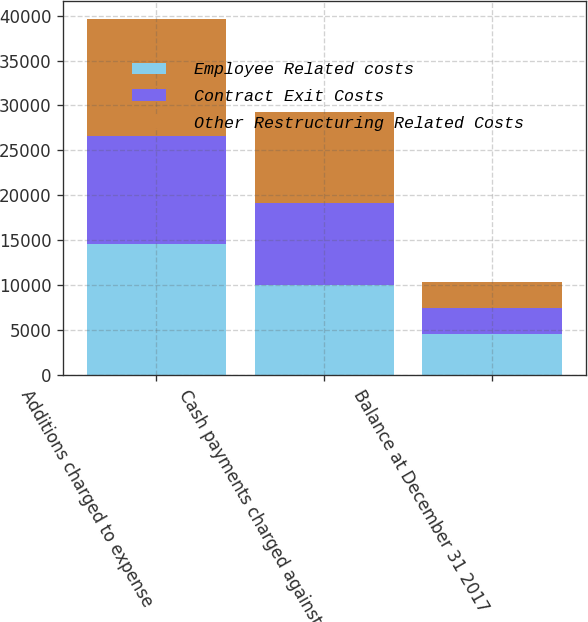Convert chart. <chart><loc_0><loc_0><loc_500><loc_500><stacked_bar_chart><ecel><fcel>Additions charged to expense<fcel>Cash payments charged against<fcel>Balance at December 31 2017<nl><fcel>Employee Related costs<fcel>14572<fcel>10017<fcel>4555<nl><fcel>Contract Exit Costs<fcel>12029<fcel>9181<fcel>2848<nl><fcel>Other Restructuring Related Costs<fcel>13070<fcel>10070<fcel>3000<nl></chart> 